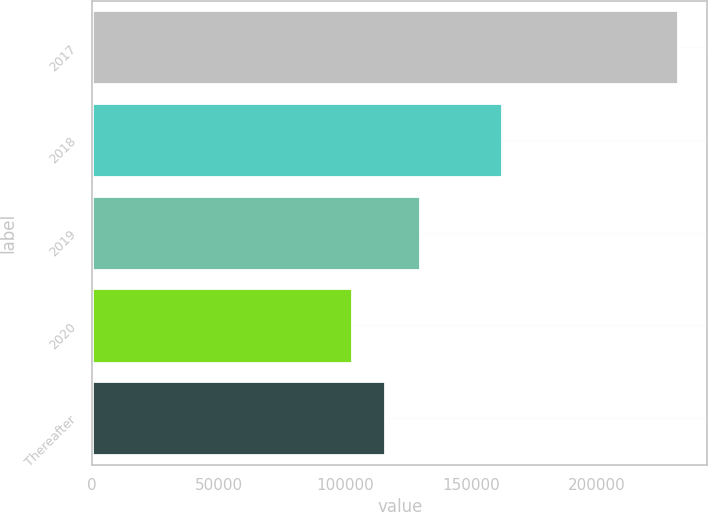Convert chart. <chart><loc_0><loc_0><loc_500><loc_500><bar_chart><fcel>2017<fcel>2018<fcel>2019<fcel>2020<fcel>Thereafter<nl><fcel>232055<fcel>162434<fcel>129920<fcel>103013<fcel>115917<nl></chart> 